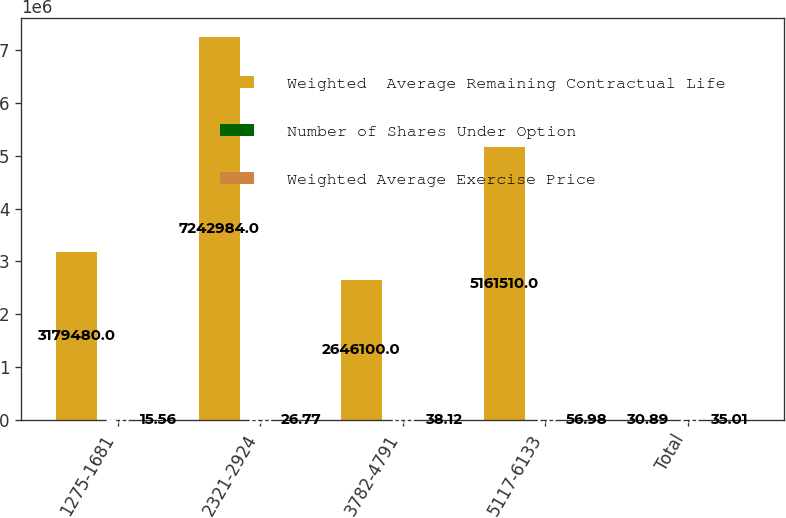<chart> <loc_0><loc_0><loc_500><loc_500><stacked_bar_chart><ecel><fcel>1275-1681<fcel>2321-2924<fcel>3782-4791<fcel>5117-6133<fcel>Total<nl><fcel>Weighted  Average Remaining Contractual Life<fcel>3.17948e+06<fcel>7.24298e+06<fcel>2.6461e+06<fcel>5.16151e+06<fcel>30.89<nl><fcel>Number of Shares Under Option<fcel>4<fcel>8<fcel>6<fcel>7<fcel>7<nl><fcel>Weighted Average Exercise Price<fcel>15.56<fcel>26.77<fcel>38.12<fcel>56.98<fcel>35.01<nl></chart> 